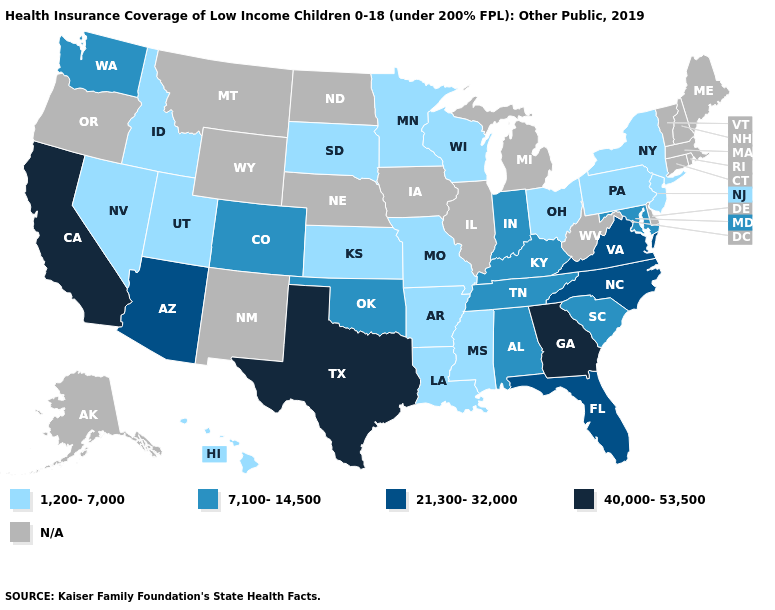What is the value of West Virginia?
Give a very brief answer. N/A. Is the legend a continuous bar?
Be succinct. No. Name the states that have a value in the range 7,100-14,500?
Concise answer only. Alabama, Colorado, Indiana, Kentucky, Maryland, Oklahoma, South Carolina, Tennessee, Washington. What is the value of Wyoming?
Concise answer only. N/A. Name the states that have a value in the range 1,200-7,000?
Answer briefly. Arkansas, Hawaii, Idaho, Kansas, Louisiana, Minnesota, Mississippi, Missouri, Nevada, New Jersey, New York, Ohio, Pennsylvania, South Dakota, Utah, Wisconsin. Among the states that border Nebraska , does Colorado have the highest value?
Quick response, please. Yes. What is the lowest value in the USA?
Keep it brief. 1,200-7,000. What is the value of New York?
Answer briefly. 1,200-7,000. Does California have the highest value in the USA?
Give a very brief answer. Yes. Does Georgia have the highest value in the South?
Answer briefly. Yes. What is the value of North Carolina?
Concise answer only. 21,300-32,000. What is the value of Connecticut?
Keep it brief. N/A. Does the first symbol in the legend represent the smallest category?
Concise answer only. Yes. 